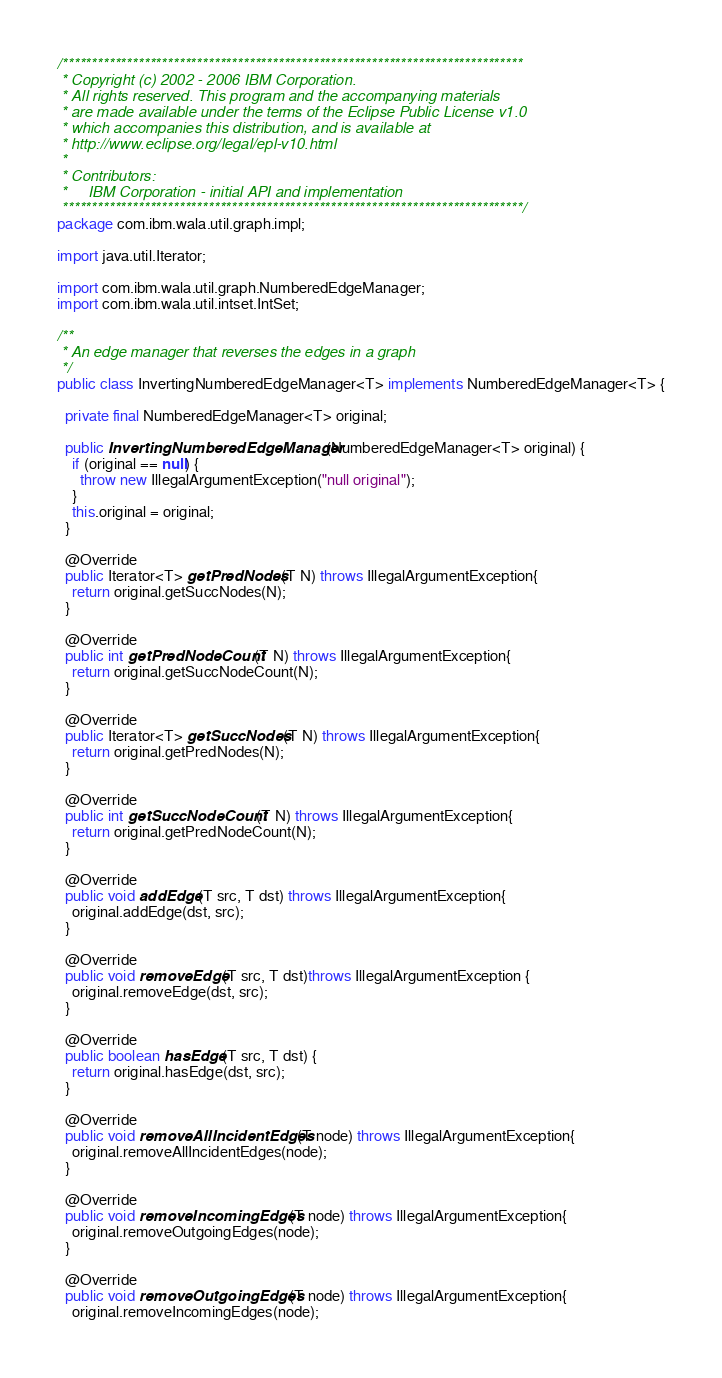<code> <loc_0><loc_0><loc_500><loc_500><_Java_>/*******************************************************************************
 * Copyright (c) 2002 - 2006 IBM Corporation.
 * All rights reserved. This program and the accompanying materials
 * are made available under the terms of the Eclipse Public License v1.0
 * which accompanies this distribution, and is available at
 * http://www.eclipse.org/legal/epl-v10.html
 *
 * Contributors:
 *     IBM Corporation - initial API and implementation
 *******************************************************************************/
package com.ibm.wala.util.graph.impl;

import java.util.Iterator;

import com.ibm.wala.util.graph.NumberedEdgeManager;
import com.ibm.wala.util.intset.IntSet;

/**
 * An edge manager that reverses the edges in a graph
 */
public class InvertingNumberedEdgeManager<T> implements NumberedEdgeManager<T> {

  private final NumberedEdgeManager<T> original;

  public InvertingNumberedEdgeManager(NumberedEdgeManager<T> original) {
    if (original == null) {
      throw new IllegalArgumentException("null original");
    }
    this.original = original;
  }

  @Override
  public Iterator<T> getPredNodes(T N) throws IllegalArgumentException{
    return original.getSuccNodes(N);
  }

  @Override
  public int getPredNodeCount(T N) throws IllegalArgumentException{
    return original.getSuccNodeCount(N);
  }

  @Override
  public Iterator<T> getSuccNodes(T N) throws IllegalArgumentException{
    return original.getPredNodes(N);
  }

  @Override
  public int getSuccNodeCount(T N) throws IllegalArgumentException{
    return original.getPredNodeCount(N);
  }

  @Override
  public void addEdge(T src, T dst) throws IllegalArgumentException{
    original.addEdge(dst, src);
  }

  @Override
  public void removeEdge(T src, T dst)throws IllegalArgumentException {
    original.removeEdge(dst, src);
  }
 
  @Override
  public boolean hasEdge(T src, T dst) {
    return original.hasEdge(dst, src);
  }

  @Override
  public void removeAllIncidentEdges(T node) throws IllegalArgumentException{
    original.removeAllIncidentEdges(node);
  }
  
  @Override
  public void removeIncomingEdges(T node) throws IllegalArgumentException{
    original.removeOutgoingEdges(node);
  }
  
  @Override
  public void removeOutgoingEdges(T node) throws IllegalArgumentException{
    original.removeIncomingEdges(node);</code> 